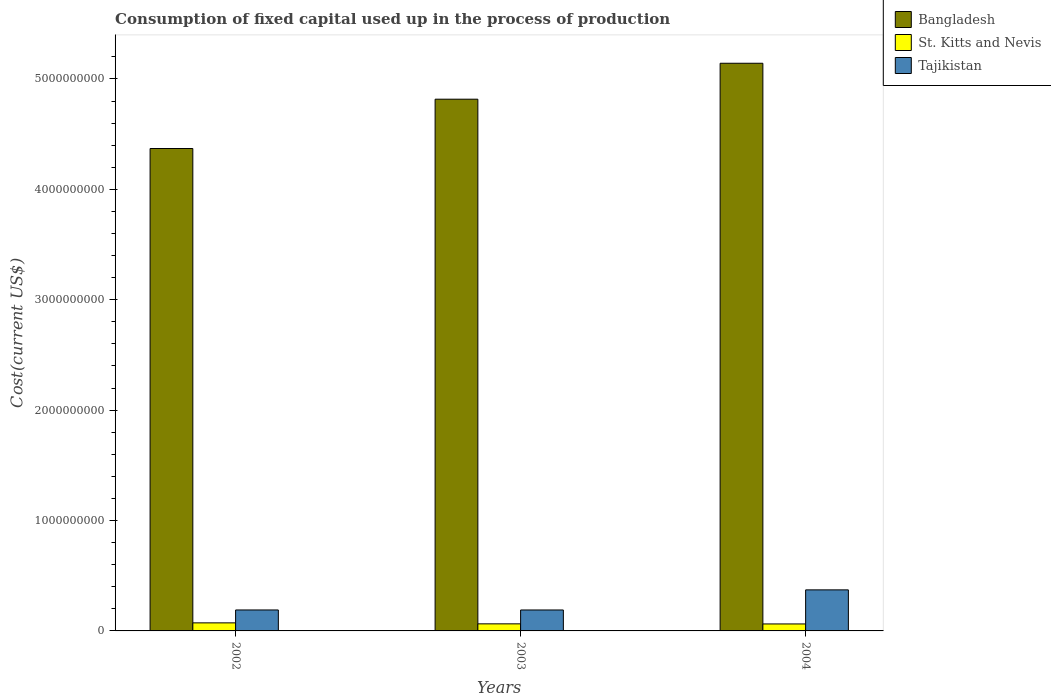How many groups of bars are there?
Give a very brief answer. 3. Are the number of bars per tick equal to the number of legend labels?
Provide a succinct answer. Yes. Are the number of bars on each tick of the X-axis equal?
Provide a succinct answer. Yes. What is the amount consumed in the process of production in Bangladesh in 2004?
Offer a terse response. 5.14e+09. Across all years, what is the maximum amount consumed in the process of production in Tajikistan?
Keep it short and to the point. 3.72e+08. Across all years, what is the minimum amount consumed in the process of production in Tajikistan?
Give a very brief answer. 1.90e+08. In which year was the amount consumed in the process of production in Tajikistan maximum?
Provide a short and direct response. 2004. What is the total amount consumed in the process of production in Tajikistan in the graph?
Ensure brevity in your answer.  7.52e+08. What is the difference between the amount consumed in the process of production in Tajikistan in 2002 and that in 2003?
Offer a terse response. 1.65e+05. What is the difference between the amount consumed in the process of production in St. Kitts and Nevis in 2002 and the amount consumed in the process of production in Tajikistan in 2004?
Offer a very short reply. -2.99e+08. What is the average amount consumed in the process of production in Tajikistan per year?
Keep it short and to the point. 2.51e+08. In the year 2003, what is the difference between the amount consumed in the process of production in Tajikistan and amount consumed in the process of production in St. Kitts and Nevis?
Ensure brevity in your answer.  1.26e+08. What is the ratio of the amount consumed in the process of production in Tajikistan in 2002 to that in 2003?
Offer a very short reply. 1. Is the amount consumed in the process of production in Tajikistan in 2002 less than that in 2004?
Give a very brief answer. Yes. What is the difference between the highest and the second highest amount consumed in the process of production in Tajikistan?
Your answer should be very brief. 1.82e+08. What is the difference between the highest and the lowest amount consumed in the process of production in Tajikistan?
Keep it short and to the point. 1.82e+08. In how many years, is the amount consumed in the process of production in Bangladesh greater than the average amount consumed in the process of production in Bangladesh taken over all years?
Provide a succinct answer. 2. Is the sum of the amount consumed in the process of production in St. Kitts and Nevis in 2002 and 2003 greater than the maximum amount consumed in the process of production in Bangladesh across all years?
Give a very brief answer. No. What does the 2nd bar from the left in 2003 represents?
Offer a terse response. St. Kitts and Nevis. What does the 2nd bar from the right in 2003 represents?
Provide a short and direct response. St. Kitts and Nevis. Are all the bars in the graph horizontal?
Your answer should be very brief. No. How many years are there in the graph?
Provide a succinct answer. 3. What is the difference between two consecutive major ticks on the Y-axis?
Your answer should be compact. 1.00e+09. Does the graph contain grids?
Offer a terse response. No. What is the title of the graph?
Ensure brevity in your answer.  Consumption of fixed capital used up in the process of production. Does "Belgium" appear as one of the legend labels in the graph?
Ensure brevity in your answer.  No. What is the label or title of the Y-axis?
Offer a very short reply. Cost(current US$). What is the Cost(current US$) in Bangladesh in 2002?
Keep it short and to the point. 4.37e+09. What is the Cost(current US$) in St. Kitts and Nevis in 2002?
Make the answer very short. 7.29e+07. What is the Cost(current US$) of Tajikistan in 2002?
Provide a succinct answer. 1.90e+08. What is the Cost(current US$) in Bangladesh in 2003?
Keep it short and to the point. 4.82e+09. What is the Cost(current US$) in St. Kitts and Nevis in 2003?
Ensure brevity in your answer.  6.41e+07. What is the Cost(current US$) in Tajikistan in 2003?
Make the answer very short. 1.90e+08. What is the Cost(current US$) in Bangladesh in 2004?
Ensure brevity in your answer.  5.14e+09. What is the Cost(current US$) in St. Kitts and Nevis in 2004?
Give a very brief answer. 6.32e+07. What is the Cost(current US$) of Tajikistan in 2004?
Provide a succinct answer. 3.72e+08. Across all years, what is the maximum Cost(current US$) of Bangladesh?
Your response must be concise. 5.14e+09. Across all years, what is the maximum Cost(current US$) in St. Kitts and Nevis?
Offer a very short reply. 7.29e+07. Across all years, what is the maximum Cost(current US$) in Tajikistan?
Your answer should be compact. 3.72e+08. Across all years, what is the minimum Cost(current US$) of Bangladesh?
Your answer should be compact. 4.37e+09. Across all years, what is the minimum Cost(current US$) in St. Kitts and Nevis?
Provide a short and direct response. 6.32e+07. Across all years, what is the minimum Cost(current US$) in Tajikistan?
Provide a succinct answer. 1.90e+08. What is the total Cost(current US$) of Bangladesh in the graph?
Your answer should be compact. 1.43e+1. What is the total Cost(current US$) of St. Kitts and Nevis in the graph?
Provide a succinct answer. 2.00e+08. What is the total Cost(current US$) in Tajikistan in the graph?
Your answer should be very brief. 7.52e+08. What is the difference between the Cost(current US$) in Bangladesh in 2002 and that in 2003?
Make the answer very short. -4.47e+08. What is the difference between the Cost(current US$) in St. Kitts and Nevis in 2002 and that in 2003?
Provide a succinct answer. 8.86e+06. What is the difference between the Cost(current US$) of Tajikistan in 2002 and that in 2003?
Your answer should be very brief. 1.65e+05. What is the difference between the Cost(current US$) in Bangladesh in 2002 and that in 2004?
Offer a very short reply. -7.72e+08. What is the difference between the Cost(current US$) in St. Kitts and Nevis in 2002 and that in 2004?
Your answer should be compact. 9.73e+06. What is the difference between the Cost(current US$) in Tajikistan in 2002 and that in 2004?
Provide a short and direct response. -1.82e+08. What is the difference between the Cost(current US$) in Bangladesh in 2003 and that in 2004?
Offer a terse response. -3.25e+08. What is the difference between the Cost(current US$) of St. Kitts and Nevis in 2003 and that in 2004?
Ensure brevity in your answer.  8.64e+05. What is the difference between the Cost(current US$) in Tajikistan in 2003 and that in 2004?
Provide a succinct answer. -1.82e+08. What is the difference between the Cost(current US$) of Bangladesh in 2002 and the Cost(current US$) of St. Kitts and Nevis in 2003?
Your answer should be compact. 4.31e+09. What is the difference between the Cost(current US$) of Bangladesh in 2002 and the Cost(current US$) of Tajikistan in 2003?
Provide a short and direct response. 4.18e+09. What is the difference between the Cost(current US$) of St. Kitts and Nevis in 2002 and the Cost(current US$) of Tajikistan in 2003?
Your answer should be very brief. -1.17e+08. What is the difference between the Cost(current US$) of Bangladesh in 2002 and the Cost(current US$) of St. Kitts and Nevis in 2004?
Make the answer very short. 4.31e+09. What is the difference between the Cost(current US$) of Bangladesh in 2002 and the Cost(current US$) of Tajikistan in 2004?
Make the answer very short. 4.00e+09. What is the difference between the Cost(current US$) in St. Kitts and Nevis in 2002 and the Cost(current US$) in Tajikistan in 2004?
Your response must be concise. -2.99e+08. What is the difference between the Cost(current US$) in Bangladesh in 2003 and the Cost(current US$) in St. Kitts and Nevis in 2004?
Your answer should be compact. 4.75e+09. What is the difference between the Cost(current US$) in Bangladesh in 2003 and the Cost(current US$) in Tajikistan in 2004?
Ensure brevity in your answer.  4.44e+09. What is the difference between the Cost(current US$) of St. Kitts and Nevis in 2003 and the Cost(current US$) of Tajikistan in 2004?
Provide a succinct answer. -3.08e+08. What is the average Cost(current US$) of Bangladesh per year?
Offer a terse response. 4.78e+09. What is the average Cost(current US$) of St. Kitts and Nevis per year?
Provide a short and direct response. 6.67e+07. What is the average Cost(current US$) in Tajikistan per year?
Your answer should be very brief. 2.51e+08. In the year 2002, what is the difference between the Cost(current US$) of Bangladesh and Cost(current US$) of St. Kitts and Nevis?
Give a very brief answer. 4.30e+09. In the year 2002, what is the difference between the Cost(current US$) of Bangladesh and Cost(current US$) of Tajikistan?
Make the answer very short. 4.18e+09. In the year 2002, what is the difference between the Cost(current US$) of St. Kitts and Nevis and Cost(current US$) of Tajikistan?
Make the answer very short. -1.17e+08. In the year 2003, what is the difference between the Cost(current US$) in Bangladesh and Cost(current US$) in St. Kitts and Nevis?
Offer a very short reply. 4.75e+09. In the year 2003, what is the difference between the Cost(current US$) in Bangladesh and Cost(current US$) in Tajikistan?
Keep it short and to the point. 4.63e+09. In the year 2003, what is the difference between the Cost(current US$) of St. Kitts and Nevis and Cost(current US$) of Tajikistan?
Make the answer very short. -1.26e+08. In the year 2004, what is the difference between the Cost(current US$) of Bangladesh and Cost(current US$) of St. Kitts and Nevis?
Offer a very short reply. 5.08e+09. In the year 2004, what is the difference between the Cost(current US$) in Bangladesh and Cost(current US$) in Tajikistan?
Provide a succinct answer. 4.77e+09. In the year 2004, what is the difference between the Cost(current US$) in St. Kitts and Nevis and Cost(current US$) in Tajikistan?
Give a very brief answer. -3.09e+08. What is the ratio of the Cost(current US$) of Bangladesh in 2002 to that in 2003?
Offer a terse response. 0.91. What is the ratio of the Cost(current US$) of St. Kitts and Nevis in 2002 to that in 2003?
Provide a succinct answer. 1.14. What is the ratio of the Cost(current US$) of Bangladesh in 2002 to that in 2004?
Offer a terse response. 0.85. What is the ratio of the Cost(current US$) of St. Kitts and Nevis in 2002 to that in 2004?
Provide a succinct answer. 1.15. What is the ratio of the Cost(current US$) of Tajikistan in 2002 to that in 2004?
Your answer should be compact. 0.51. What is the ratio of the Cost(current US$) of Bangladesh in 2003 to that in 2004?
Ensure brevity in your answer.  0.94. What is the ratio of the Cost(current US$) of St. Kitts and Nevis in 2003 to that in 2004?
Keep it short and to the point. 1.01. What is the ratio of the Cost(current US$) of Tajikistan in 2003 to that in 2004?
Give a very brief answer. 0.51. What is the difference between the highest and the second highest Cost(current US$) of Bangladesh?
Offer a terse response. 3.25e+08. What is the difference between the highest and the second highest Cost(current US$) of St. Kitts and Nevis?
Offer a terse response. 8.86e+06. What is the difference between the highest and the second highest Cost(current US$) in Tajikistan?
Your response must be concise. 1.82e+08. What is the difference between the highest and the lowest Cost(current US$) of Bangladesh?
Offer a very short reply. 7.72e+08. What is the difference between the highest and the lowest Cost(current US$) in St. Kitts and Nevis?
Your response must be concise. 9.73e+06. What is the difference between the highest and the lowest Cost(current US$) in Tajikistan?
Make the answer very short. 1.82e+08. 